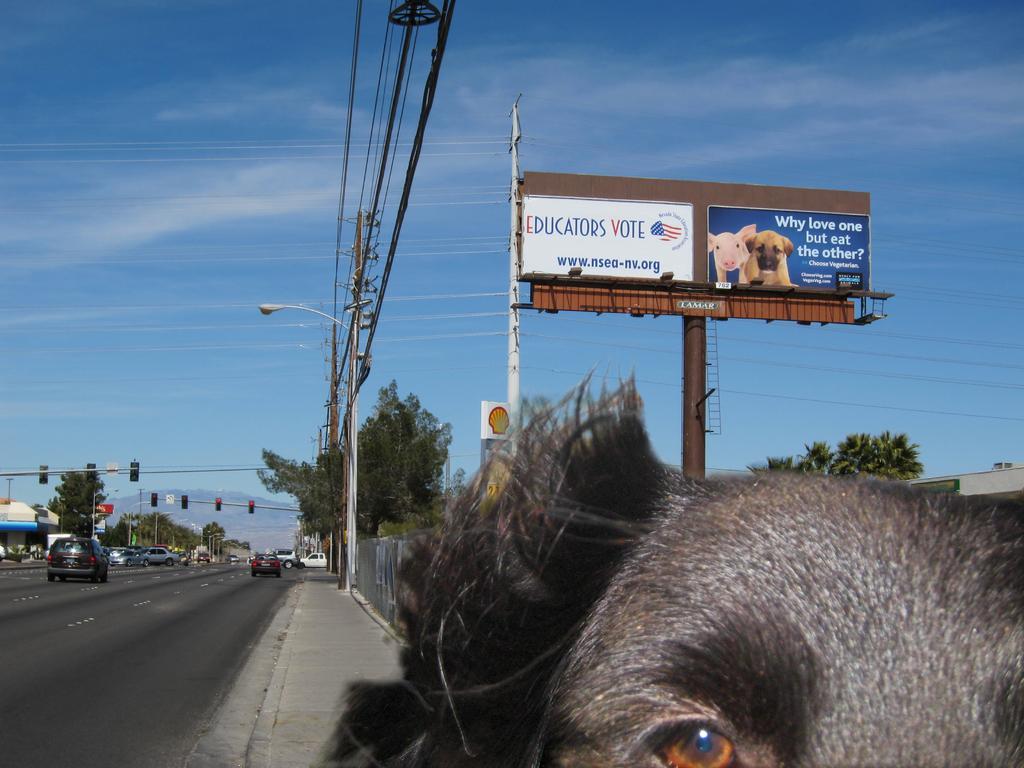Can you describe this image briefly? In the center of the image we can see the electric light poles, trees, wires, boards. On the right side of the image we can see a building. In the bottom right corner we can see an animal. On the left side of the image we can see the buildings, trees, some vehicles, traffic lights, hills. At the bottom of the image we can see the road. At the top of the image we can see the clouds are present in the sky. 